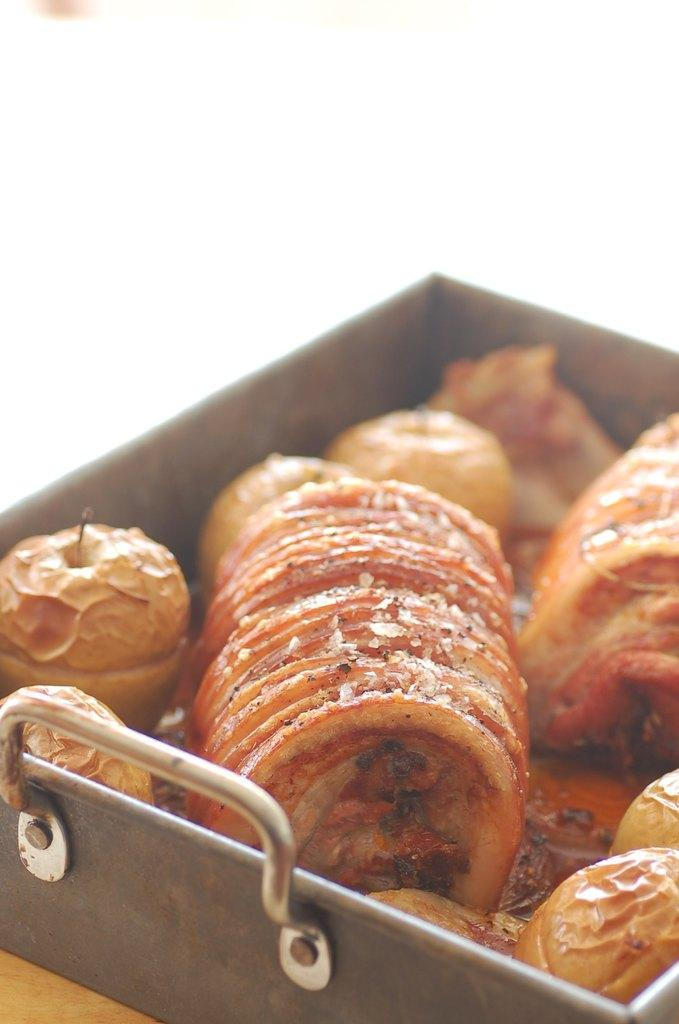What is present on the tray in the image? There is food in a tray in the image. What can be seen in the background of the image? The background of the image is white. What type of writing can be seen on the food in the image? There is no writing present on the food in the image. Can you compare the size of the food in the tray to the size of the tray itself? It is not possible to make a comparison between the size of the food and the tray based on the information provided in the image. 